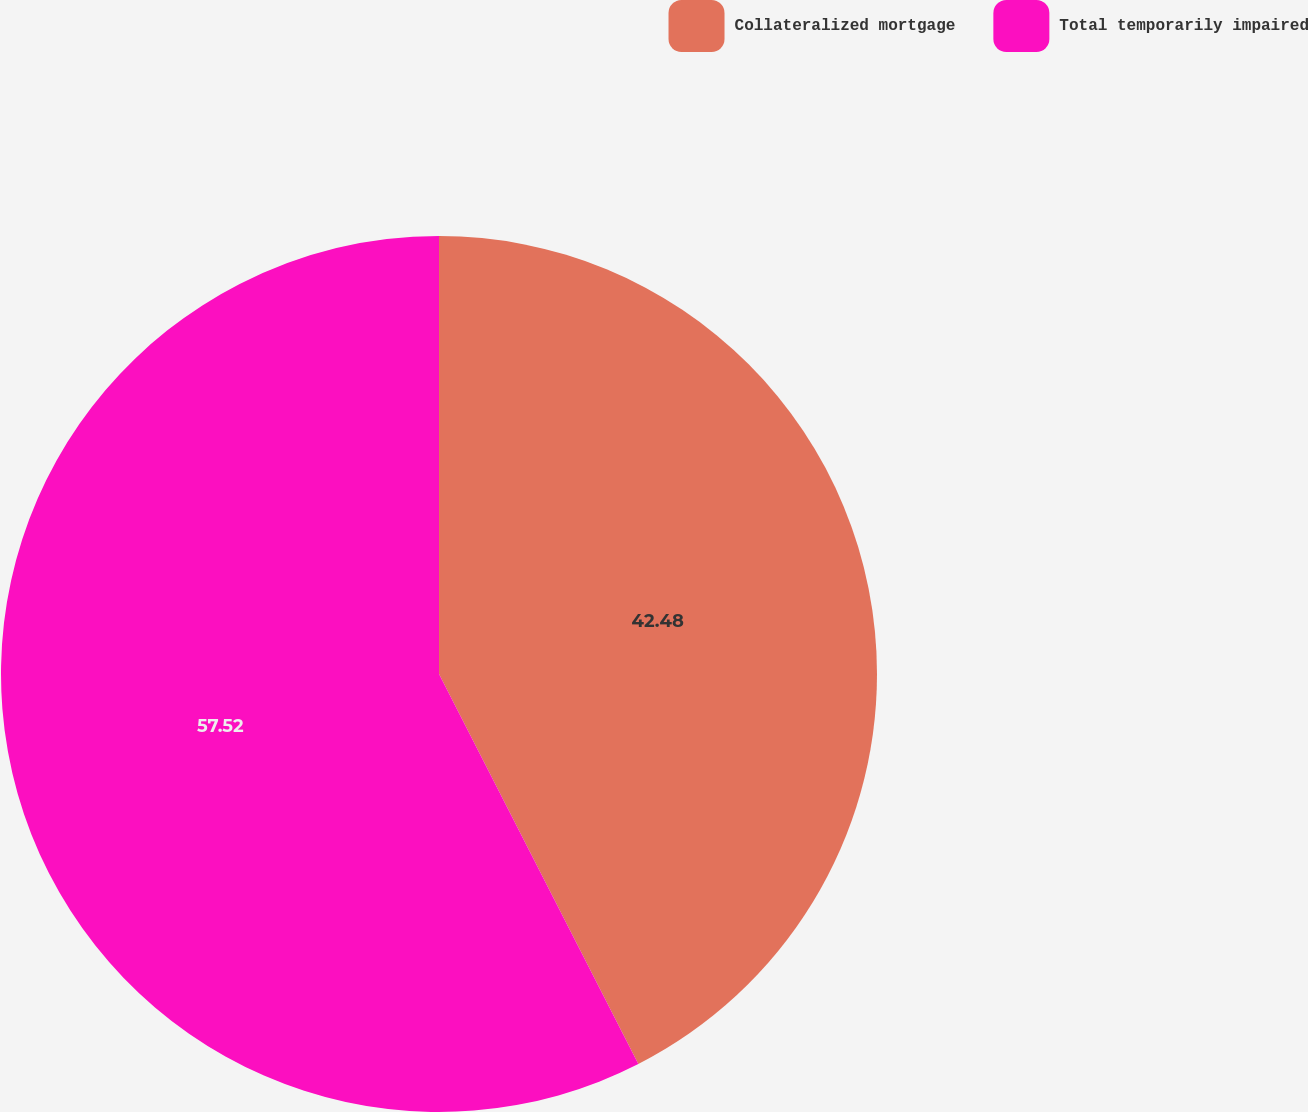Convert chart. <chart><loc_0><loc_0><loc_500><loc_500><pie_chart><fcel>Collateralized mortgage<fcel>Total temporarily impaired<nl><fcel>42.48%<fcel>57.52%<nl></chart> 